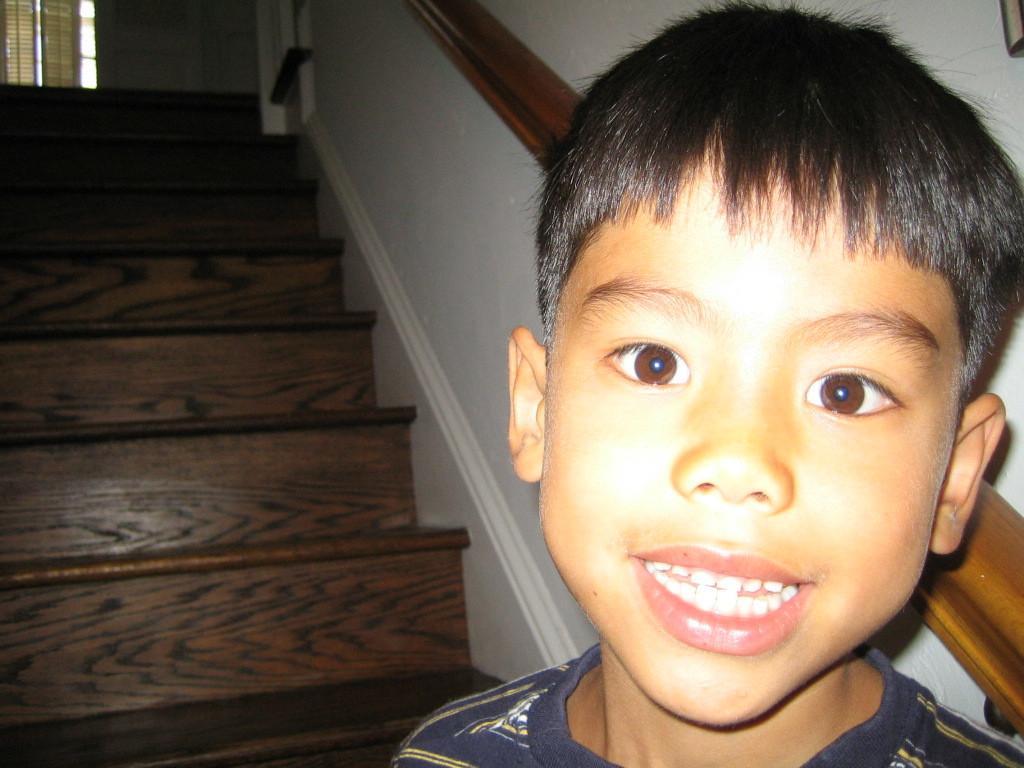Could you give a brief overview of what you see in this image? This image is taken indoors. In the background there is a wall. There are few stairs and there is a window blind. On the right side of the image there is a kid. 